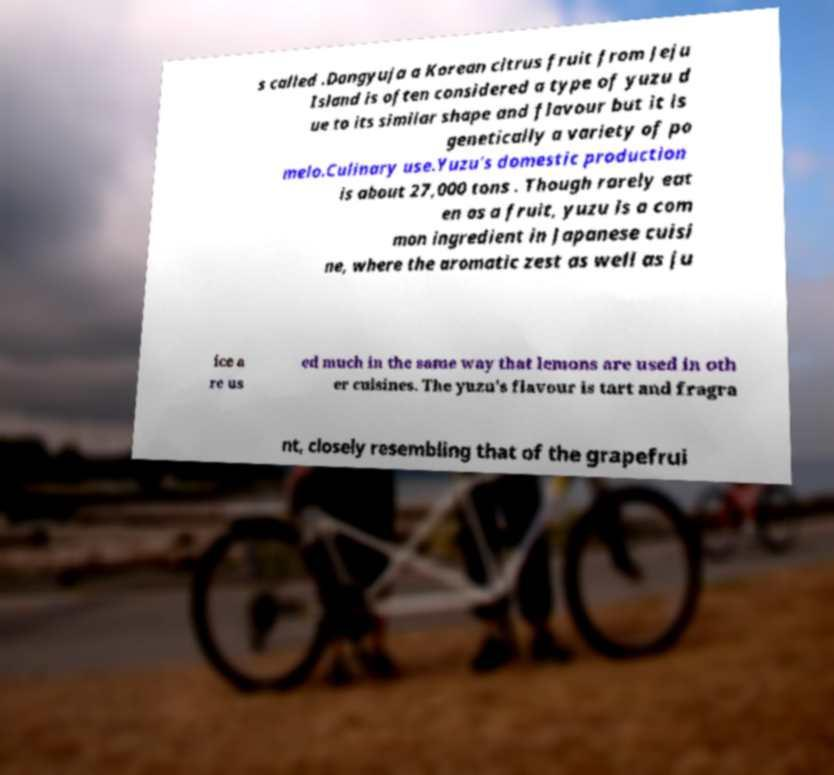Please identify and transcribe the text found in this image. s called .Dangyuja a Korean citrus fruit from Jeju Island is often considered a type of yuzu d ue to its similar shape and flavour but it is genetically a variety of po melo.Culinary use.Yuzu's domestic production is about 27,000 tons . Though rarely eat en as a fruit, yuzu is a com mon ingredient in Japanese cuisi ne, where the aromatic zest as well as ju ice a re us ed much in the same way that lemons are used in oth er cuisines. The yuzu's flavour is tart and fragra nt, closely resembling that of the grapefrui 